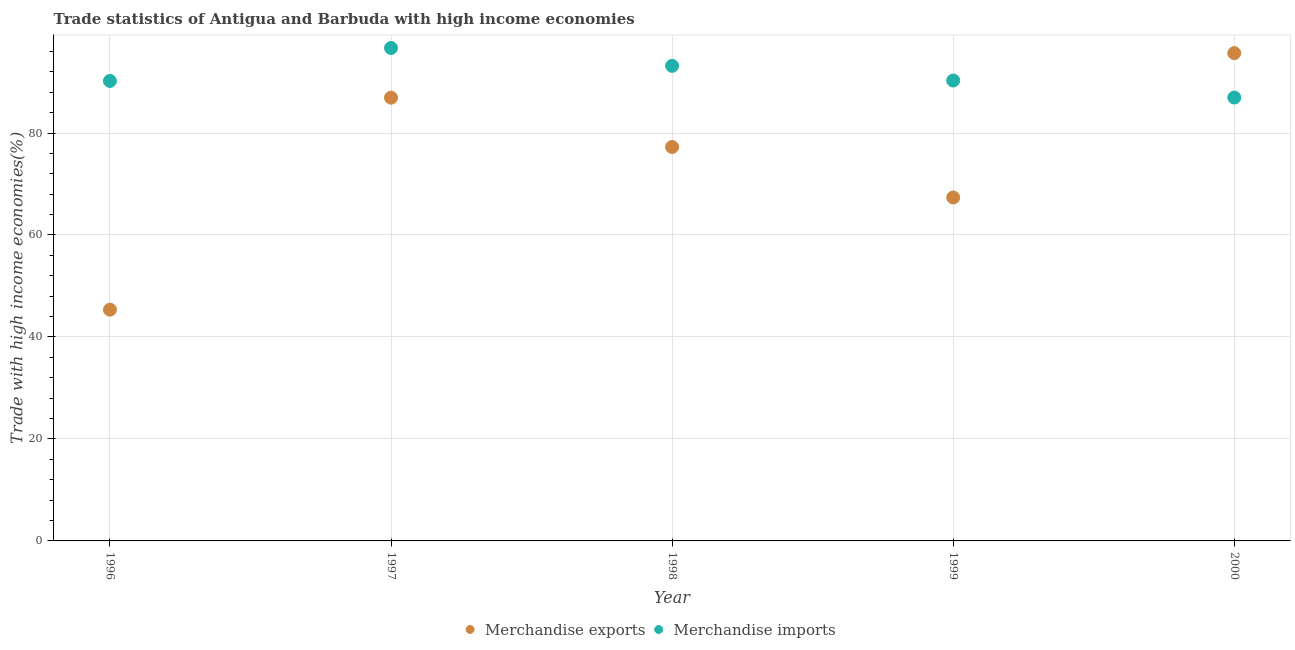How many different coloured dotlines are there?
Provide a short and direct response. 2. What is the merchandise exports in 1999?
Keep it short and to the point. 67.35. Across all years, what is the maximum merchandise imports?
Make the answer very short. 96.68. Across all years, what is the minimum merchandise imports?
Provide a short and direct response. 86.95. In which year was the merchandise exports maximum?
Offer a very short reply. 2000. What is the total merchandise imports in the graph?
Your answer should be very brief. 457.31. What is the difference between the merchandise imports in 1996 and that in 1999?
Provide a succinct answer. -0.09. What is the difference between the merchandise exports in 1997 and the merchandise imports in 1998?
Provide a succinct answer. -6.24. What is the average merchandise imports per year?
Offer a very short reply. 91.46. In the year 1996, what is the difference between the merchandise imports and merchandise exports?
Your answer should be very brief. 44.85. What is the ratio of the merchandise exports in 1997 to that in 1999?
Give a very brief answer. 1.29. What is the difference between the highest and the second highest merchandise exports?
Your answer should be very brief. 8.74. What is the difference between the highest and the lowest merchandise imports?
Offer a terse response. 9.72. Does the merchandise exports monotonically increase over the years?
Your answer should be very brief. No. Is the merchandise imports strictly less than the merchandise exports over the years?
Make the answer very short. No. What is the difference between two consecutive major ticks on the Y-axis?
Ensure brevity in your answer.  20. Are the values on the major ticks of Y-axis written in scientific E-notation?
Your answer should be very brief. No. Does the graph contain any zero values?
Ensure brevity in your answer.  No. How many legend labels are there?
Your answer should be compact. 2. What is the title of the graph?
Keep it short and to the point. Trade statistics of Antigua and Barbuda with high income economies. Does "Current US$" appear as one of the legend labels in the graph?
Provide a short and direct response. No. What is the label or title of the X-axis?
Your answer should be very brief. Year. What is the label or title of the Y-axis?
Make the answer very short. Trade with high income economies(%). What is the Trade with high income economies(%) in Merchandise exports in 1996?
Your answer should be very brief. 45.35. What is the Trade with high income economies(%) in Merchandise imports in 1996?
Give a very brief answer. 90.21. What is the Trade with high income economies(%) in Merchandise exports in 1997?
Your answer should be very brief. 86.93. What is the Trade with high income economies(%) of Merchandise imports in 1997?
Your answer should be compact. 96.68. What is the Trade with high income economies(%) in Merchandise exports in 1998?
Ensure brevity in your answer.  77.26. What is the Trade with high income economies(%) in Merchandise imports in 1998?
Offer a terse response. 93.17. What is the Trade with high income economies(%) in Merchandise exports in 1999?
Provide a succinct answer. 67.35. What is the Trade with high income economies(%) of Merchandise imports in 1999?
Provide a short and direct response. 90.29. What is the Trade with high income economies(%) in Merchandise exports in 2000?
Your answer should be compact. 95.67. What is the Trade with high income economies(%) of Merchandise imports in 2000?
Keep it short and to the point. 86.95. Across all years, what is the maximum Trade with high income economies(%) of Merchandise exports?
Offer a terse response. 95.67. Across all years, what is the maximum Trade with high income economies(%) in Merchandise imports?
Provide a succinct answer. 96.68. Across all years, what is the minimum Trade with high income economies(%) of Merchandise exports?
Provide a short and direct response. 45.35. Across all years, what is the minimum Trade with high income economies(%) in Merchandise imports?
Give a very brief answer. 86.95. What is the total Trade with high income economies(%) of Merchandise exports in the graph?
Your answer should be very brief. 372.56. What is the total Trade with high income economies(%) in Merchandise imports in the graph?
Your response must be concise. 457.31. What is the difference between the Trade with high income economies(%) of Merchandise exports in 1996 and that in 1997?
Provide a short and direct response. -41.58. What is the difference between the Trade with high income economies(%) in Merchandise imports in 1996 and that in 1997?
Offer a terse response. -6.47. What is the difference between the Trade with high income economies(%) in Merchandise exports in 1996 and that in 1998?
Offer a terse response. -31.91. What is the difference between the Trade with high income economies(%) in Merchandise imports in 1996 and that in 1998?
Make the answer very short. -2.96. What is the difference between the Trade with high income economies(%) in Merchandise exports in 1996 and that in 1999?
Your response must be concise. -22. What is the difference between the Trade with high income economies(%) of Merchandise imports in 1996 and that in 1999?
Offer a terse response. -0.09. What is the difference between the Trade with high income economies(%) in Merchandise exports in 1996 and that in 2000?
Your answer should be very brief. -50.31. What is the difference between the Trade with high income economies(%) in Merchandise imports in 1996 and that in 2000?
Ensure brevity in your answer.  3.25. What is the difference between the Trade with high income economies(%) in Merchandise exports in 1997 and that in 1998?
Make the answer very short. 9.67. What is the difference between the Trade with high income economies(%) of Merchandise imports in 1997 and that in 1998?
Keep it short and to the point. 3.51. What is the difference between the Trade with high income economies(%) in Merchandise exports in 1997 and that in 1999?
Provide a succinct answer. 19.58. What is the difference between the Trade with high income economies(%) in Merchandise imports in 1997 and that in 1999?
Make the answer very short. 6.38. What is the difference between the Trade with high income economies(%) of Merchandise exports in 1997 and that in 2000?
Offer a very short reply. -8.74. What is the difference between the Trade with high income economies(%) of Merchandise imports in 1997 and that in 2000?
Give a very brief answer. 9.72. What is the difference between the Trade with high income economies(%) in Merchandise exports in 1998 and that in 1999?
Provide a short and direct response. 9.91. What is the difference between the Trade with high income economies(%) in Merchandise imports in 1998 and that in 1999?
Give a very brief answer. 2.88. What is the difference between the Trade with high income economies(%) of Merchandise exports in 1998 and that in 2000?
Your response must be concise. -18.41. What is the difference between the Trade with high income economies(%) of Merchandise imports in 1998 and that in 2000?
Offer a very short reply. 6.22. What is the difference between the Trade with high income economies(%) in Merchandise exports in 1999 and that in 2000?
Make the answer very short. -28.32. What is the difference between the Trade with high income economies(%) in Merchandise imports in 1999 and that in 2000?
Offer a very short reply. 3.34. What is the difference between the Trade with high income economies(%) of Merchandise exports in 1996 and the Trade with high income economies(%) of Merchandise imports in 1997?
Your response must be concise. -51.33. What is the difference between the Trade with high income economies(%) in Merchandise exports in 1996 and the Trade with high income economies(%) in Merchandise imports in 1998?
Provide a succinct answer. -47.82. What is the difference between the Trade with high income economies(%) in Merchandise exports in 1996 and the Trade with high income economies(%) in Merchandise imports in 1999?
Provide a succinct answer. -44.94. What is the difference between the Trade with high income economies(%) in Merchandise exports in 1996 and the Trade with high income economies(%) in Merchandise imports in 2000?
Keep it short and to the point. -41.6. What is the difference between the Trade with high income economies(%) in Merchandise exports in 1997 and the Trade with high income economies(%) in Merchandise imports in 1998?
Your answer should be very brief. -6.24. What is the difference between the Trade with high income economies(%) of Merchandise exports in 1997 and the Trade with high income economies(%) of Merchandise imports in 1999?
Your answer should be very brief. -3.36. What is the difference between the Trade with high income economies(%) in Merchandise exports in 1997 and the Trade with high income economies(%) in Merchandise imports in 2000?
Provide a short and direct response. -0.02. What is the difference between the Trade with high income economies(%) in Merchandise exports in 1998 and the Trade with high income economies(%) in Merchandise imports in 1999?
Offer a very short reply. -13.03. What is the difference between the Trade with high income economies(%) in Merchandise exports in 1998 and the Trade with high income economies(%) in Merchandise imports in 2000?
Your answer should be compact. -9.69. What is the difference between the Trade with high income economies(%) of Merchandise exports in 1999 and the Trade with high income economies(%) of Merchandise imports in 2000?
Make the answer very short. -19.6. What is the average Trade with high income economies(%) in Merchandise exports per year?
Your answer should be very brief. 74.51. What is the average Trade with high income economies(%) of Merchandise imports per year?
Your response must be concise. 91.46. In the year 1996, what is the difference between the Trade with high income economies(%) in Merchandise exports and Trade with high income economies(%) in Merchandise imports?
Give a very brief answer. -44.85. In the year 1997, what is the difference between the Trade with high income economies(%) of Merchandise exports and Trade with high income economies(%) of Merchandise imports?
Offer a very short reply. -9.75. In the year 1998, what is the difference between the Trade with high income economies(%) in Merchandise exports and Trade with high income economies(%) in Merchandise imports?
Offer a terse response. -15.91. In the year 1999, what is the difference between the Trade with high income economies(%) of Merchandise exports and Trade with high income economies(%) of Merchandise imports?
Your answer should be compact. -22.94. In the year 2000, what is the difference between the Trade with high income economies(%) of Merchandise exports and Trade with high income economies(%) of Merchandise imports?
Provide a succinct answer. 8.71. What is the ratio of the Trade with high income economies(%) in Merchandise exports in 1996 to that in 1997?
Keep it short and to the point. 0.52. What is the ratio of the Trade with high income economies(%) in Merchandise imports in 1996 to that in 1997?
Your response must be concise. 0.93. What is the ratio of the Trade with high income economies(%) in Merchandise exports in 1996 to that in 1998?
Your response must be concise. 0.59. What is the ratio of the Trade with high income economies(%) in Merchandise imports in 1996 to that in 1998?
Provide a succinct answer. 0.97. What is the ratio of the Trade with high income economies(%) in Merchandise exports in 1996 to that in 1999?
Your answer should be very brief. 0.67. What is the ratio of the Trade with high income economies(%) of Merchandise imports in 1996 to that in 1999?
Your response must be concise. 1. What is the ratio of the Trade with high income economies(%) of Merchandise exports in 1996 to that in 2000?
Make the answer very short. 0.47. What is the ratio of the Trade with high income economies(%) of Merchandise imports in 1996 to that in 2000?
Your answer should be very brief. 1.04. What is the ratio of the Trade with high income economies(%) of Merchandise exports in 1997 to that in 1998?
Your response must be concise. 1.13. What is the ratio of the Trade with high income economies(%) of Merchandise imports in 1997 to that in 1998?
Your answer should be compact. 1.04. What is the ratio of the Trade with high income economies(%) of Merchandise exports in 1997 to that in 1999?
Offer a very short reply. 1.29. What is the ratio of the Trade with high income economies(%) of Merchandise imports in 1997 to that in 1999?
Your response must be concise. 1.07. What is the ratio of the Trade with high income economies(%) of Merchandise exports in 1997 to that in 2000?
Provide a short and direct response. 0.91. What is the ratio of the Trade with high income economies(%) of Merchandise imports in 1997 to that in 2000?
Your response must be concise. 1.11. What is the ratio of the Trade with high income economies(%) of Merchandise exports in 1998 to that in 1999?
Keep it short and to the point. 1.15. What is the ratio of the Trade with high income economies(%) in Merchandise imports in 1998 to that in 1999?
Your answer should be compact. 1.03. What is the ratio of the Trade with high income economies(%) of Merchandise exports in 1998 to that in 2000?
Offer a terse response. 0.81. What is the ratio of the Trade with high income economies(%) of Merchandise imports in 1998 to that in 2000?
Your response must be concise. 1.07. What is the ratio of the Trade with high income economies(%) of Merchandise exports in 1999 to that in 2000?
Offer a very short reply. 0.7. What is the ratio of the Trade with high income economies(%) of Merchandise imports in 1999 to that in 2000?
Your answer should be compact. 1.04. What is the difference between the highest and the second highest Trade with high income economies(%) in Merchandise exports?
Provide a short and direct response. 8.74. What is the difference between the highest and the second highest Trade with high income economies(%) in Merchandise imports?
Your answer should be very brief. 3.51. What is the difference between the highest and the lowest Trade with high income economies(%) of Merchandise exports?
Offer a terse response. 50.31. What is the difference between the highest and the lowest Trade with high income economies(%) in Merchandise imports?
Your response must be concise. 9.72. 